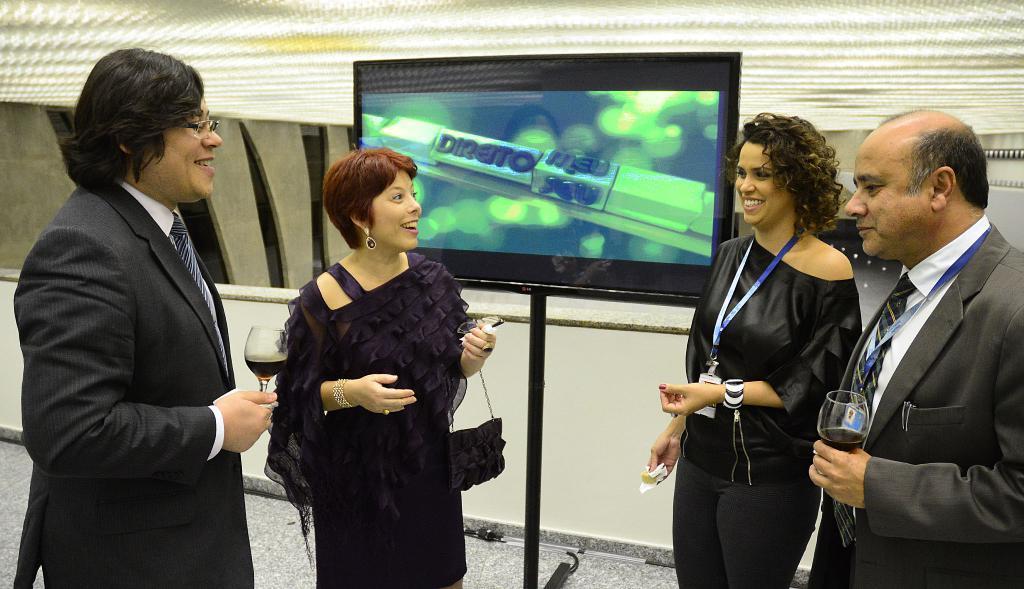Please provide a concise description of this image. Here people are standing. This is glass, bag, television, this is wall. 